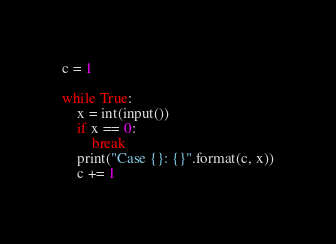<code> <loc_0><loc_0><loc_500><loc_500><_Python_>c = 1

while True:
    x = int(input())
    if x == 0:
        break
    print("Case {}: {}".format(c, x))
    c += 1

</code> 